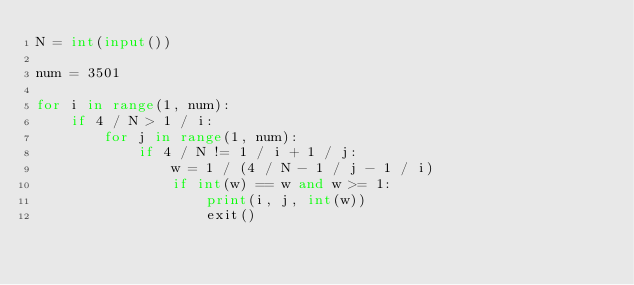Convert code to text. <code><loc_0><loc_0><loc_500><loc_500><_Python_>N = int(input())

num = 3501

for i in range(1, num):
    if 4 / N > 1 / i:
        for j in range(1, num):
            if 4 / N != 1 / i + 1 / j:
                w = 1 / (4 / N - 1 / j - 1 / i)
                if int(w) == w and w >= 1:
                    print(i, j, int(w))
                    exit()</code> 